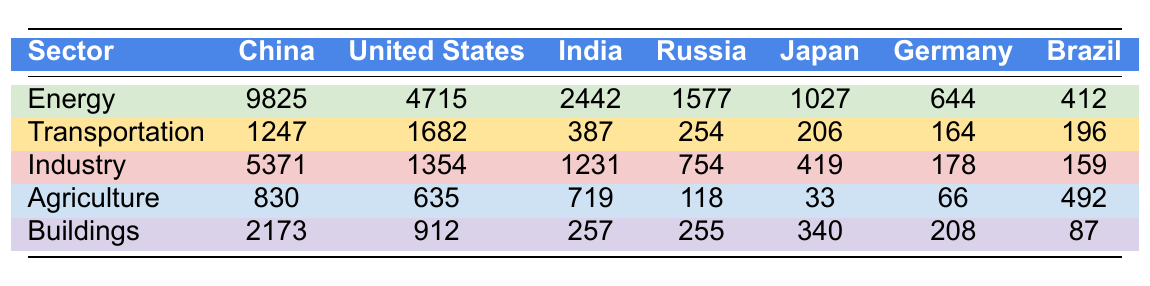What are the total emissions for China across all sectors? To find the total emissions for China, we sum the emissions from each sector: Energy (9825) + Transportation (1247) + Industry (5371) + Agriculture (830) + Buildings (2173) = 19646
Answer: 19646 Which sector has the highest emissions in the United States? By comparing the emissions figures for the United States across all sectors, we see that Energy has the highest emissions at 4715.
Answer: Energy What are India's emissions from Agriculture and Transportation combined? We sum India's emissions from these two sectors: Agriculture (719) + Transportation (387) = 1106.
Answer: 1106 Is the total carbon emissions from the Buildings sector in Japan greater than in Germany? Japan has 340 emissions from Buildings while Germany has 208. Since 340 is greater than 208, the statement is true.
Answer: Yes Which country has the highest emissions in the Industry sector? Looking at the Industry sector, China has the highest emissions at 5371.
Answer: China What is the average emission for Brazil across all sectors? To calculate the average, sum Brazil's emissions across all sectors: Energy (412) + Transportation (196) + Industry (159) + Agriculture (492) + Buildings (87) = 1346, then divide by 5 (the number of sectors), which gives 1346 / 5 = 269.2.
Answer: 269.2 Which sector's emissions are closest in Canada to Germany's emissions? Looking at the emissions for Canada: Energy (553), Transportation (186), Industry (191), Agriculture (73), and Buildings (86), the closest match to Germany’s emissions (Energy 644, Transportation 164, Industry 178, Agriculture 66, Buildings 208) is Industry from Canada at 191 to Germany's 178.
Answer: Industry What is the difference in emissions between the Energy sector and the Agriculture sector for Russia? Subtract the emissions from Agriculture (118) from Energy (1577): 1577 - 118 = 1459.
Answer: 1459 Are total emissions from the Transportation sector across all countries greater than 5000? Summing the emissions from the Transportation sector: 1247 (China) + 1682 (United States) + 387 (India) + 254 (Russia) + 206 (Japan) + 164 (Germany) + 196 (Brazil) + 186 (Canada) gives a total of 4122, which is less than 5000.
Answer: No What percentage of total emissions from China is contributed by the Industry sector? First, sum the total emissions for China (19646). Industry emissions are 5371. To find the percentage: (5371 / 19646) * 100 ≈ 27.3%.
Answer: 27.3% 